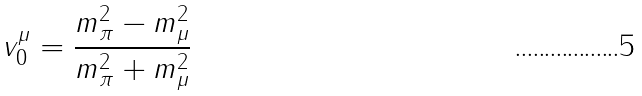Convert formula to latex. <formula><loc_0><loc_0><loc_500><loc_500>v _ { 0 } ^ { \mu } = \frac { m _ { \pi } ^ { 2 } - m _ { \mu } ^ { 2 } } { m _ { \pi } ^ { 2 } + m _ { \mu } ^ { 2 } }</formula> 